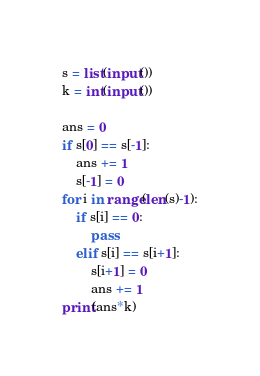Convert code to text. <code><loc_0><loc_0><loc_500><loc_500><_Python_>s = list(input())
k = int(input())

ans = 0
if s[0] == s[-1]:
    ans += 1
    s[-1] = 0
for i in range(len(s)-1):
    if s[i] == 0:
        pass
    elif s[i] == s[i+1]:
        s[i+1] = 0
        ans += 1
print(ans*k)
</code> 